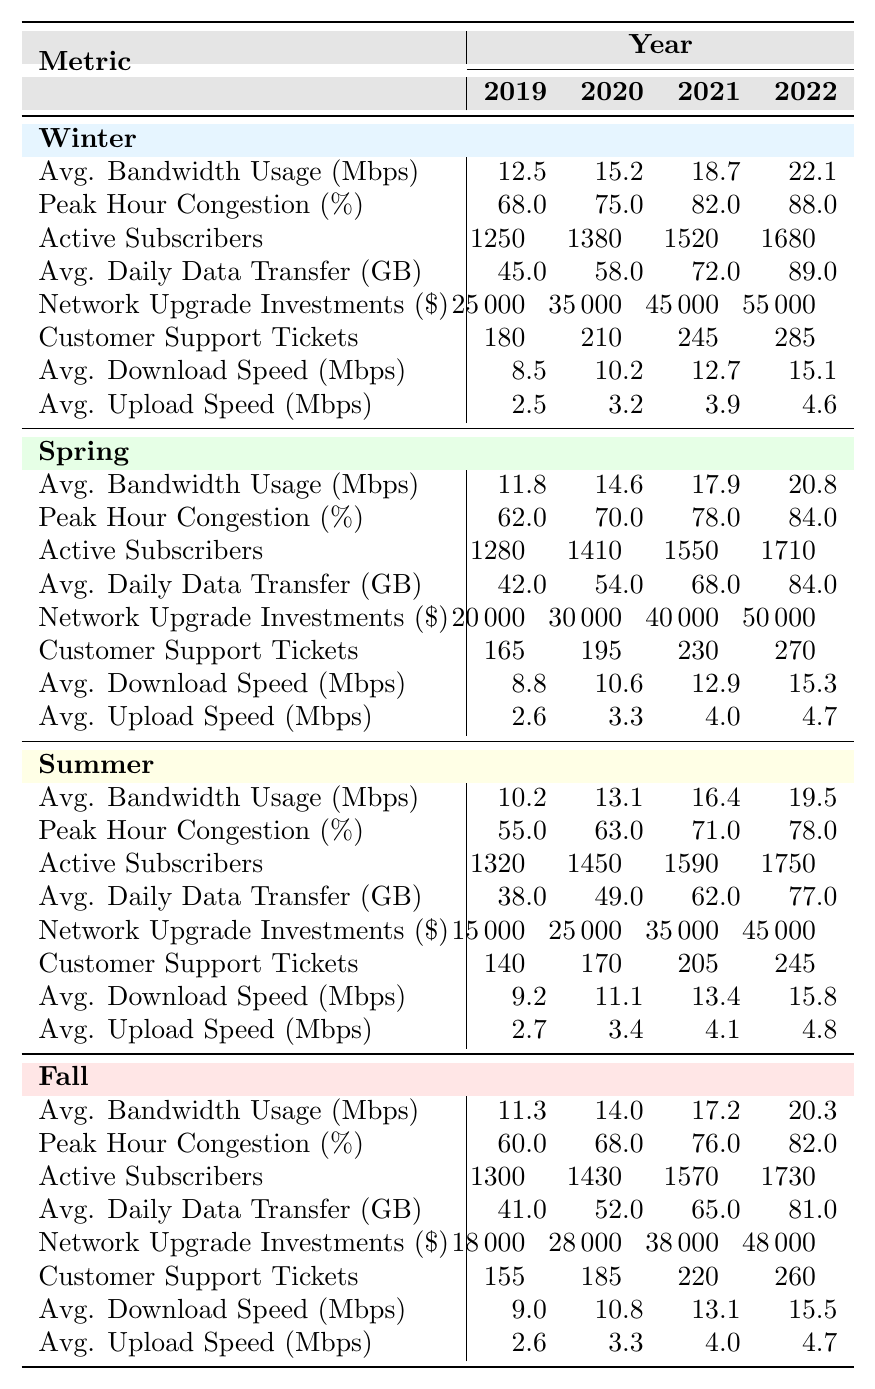What was the average bandwidth usage in Winter for the year 2022? The table states that the average bandwidth usage for Winter in 2022 is 22.1 Mbps.
Answer: 22.1 Mbps Which season had the highest peak hour congestion percentage in 2021? In 2021, the peak hour congestion percentages were as follows: Winter 82%, Spring 78%, Summer 71%, Fall 76%. Winter had the highest percentage at 82%.
Answer: Winter How many active subscribers were there in Spring 2020? The table shows that there were 1410 active subscribers in Spring 2020.
Answer: 1410 What was the change in average daily data transfer from Summer 2019 to Summer 2022? The average daily data transfer for Summer 2019 was 38 GB and for Summer 2022 was 77 GB. The change is 77 - 38 = 39 GB.
Answer: 39 GB Is it true that Winter has the highest average download speed in 2022 compared to other seasons? In 2022, the average download speeds were Winter 15.1 Mbps, Spring 15.3 Mbps, Summer 15.8 Mbps, and Fall 15.5 Mbps. Spring has the highest average download speed, so the statement is false.
Answer: No What is the overall trend in average bandwidth usage from 2019 to 2022 across all seasons? By observing the average bandwidth usage for each season, we see increases from 2019 to 2022: Winter (12.5 to 22.1), Spring (11.8 to 20.8), Summer (10.2 to 19.5), and Fall (11.3 to 20.3). Therefore, the trend shows an upward increase.
Answer: Increased What was the percentage increase in network upgrade investments in Winter from 2019 to 2022? The investments rose from $25,000 in 2019 to $55,000 in 2022. The increase is $55,000 - $25,000 = $30,000. The percentage increase is ($30,000 / $25,000) * 100% = 120%.
Answer: 120% Which season had the lowest customer support tickets related to speed in 2021? The number of customer support tickets in 2021 were Winter 245, Spring 230, Summer 205, and Fall 220. Summer had the lowest at 205 tickets.
Answer: Summer In how many years did Fall have an average bandwidth usage greater than 17 Mbps? Looking at the values for Fall: 2019 (11.3), 2020 (14.0), 2021 (17.2), and 2022 (20.3). Fall exceeded 17 Mbps in 2021 and 2022, totaling 2 years.
Answer: 2 years What was the average upload speed in Spring for the year 2021? The table indicates that the average upload speed in Spring for 2021 was 4.0 Mbps.
Answer: 4.0 Mbps 